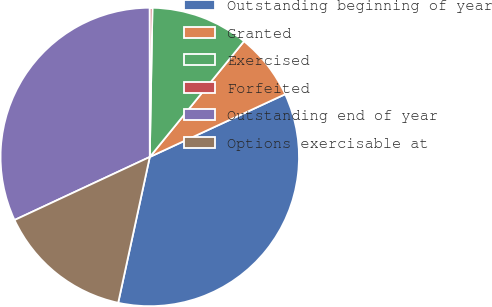Convert chart. <chart><loc_0><loc_0><loc_500><loc_500><pie_chart><fcel>Outstanding beginning of year<fcel>Granted<fcel>Exercised<fcel>Forfeited<fcel>Outstanding end of year<fcel>Options exercisable at<nl><fcel>35.3%<fcel>7.22%<fcel>10.59%<fcel>0.3%<fcel>31.93%<fcel>14.66%<nl></chart> 